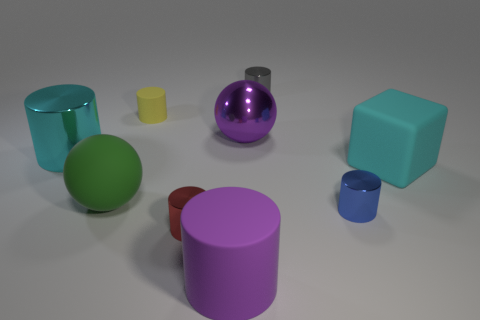Subtract all shiny cylinders. How many cylinders are left? 2 Subtract all purple cylinders. How many cylinders are left? 5 Add 1 gray objects. How many objects exist? 10 Subtract all cylinders. How many objects are left? 3 Subtract 1 cubes. How many cubes are left? 0 Add 9 yellow things. How many yellow things are left? 10 Add 5 red metallic things. How many red metallic things exist? 6 Subtract 0 gray balls. How many objects are left? 9 Subtract all gray cylinders. Subtract all purple balls. How many cylinders are left? 5 Subtract all cyan cubes. How many purple spheres are left? 1 